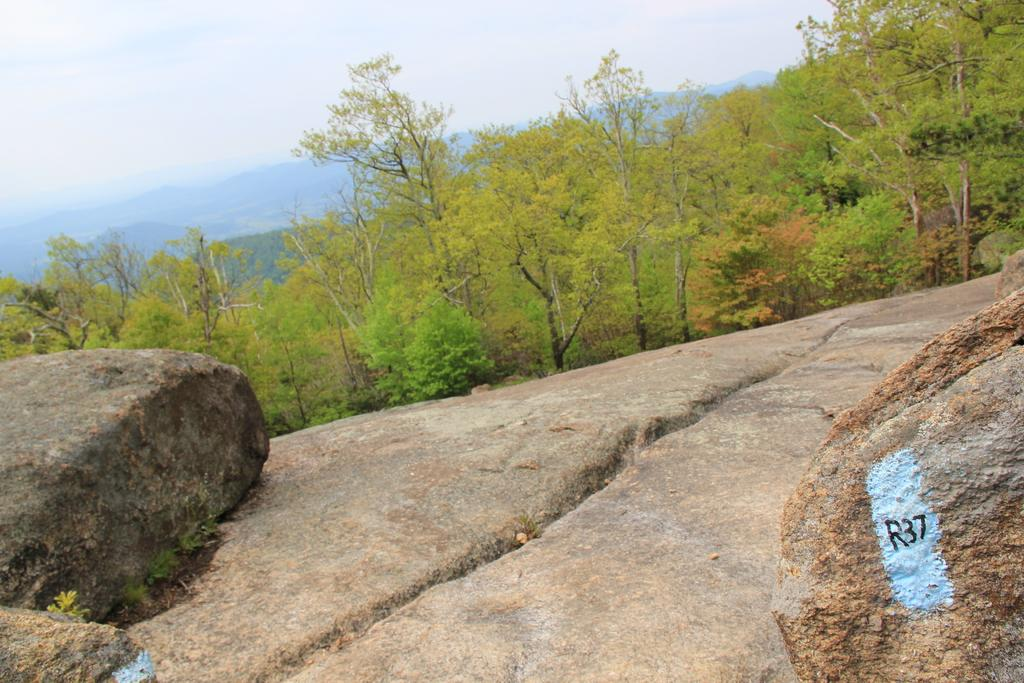What is located on the left side of the image? There is a large stone on the left side of the image. What type of vegetation can be seen in the image? There are trees in the image. What can be seen in the background of the image? Hills and the sky are visible in the background of the image. What is the condition of the sky in the image? The sky has clouds in it. How many boys are playing with the mice in the image? There are no boys or mice present in the image. What type of downtown area can be seen in the image? There is no downtown area visible in the image; it features a large stone, trees, hills, and a sky with clouds. 